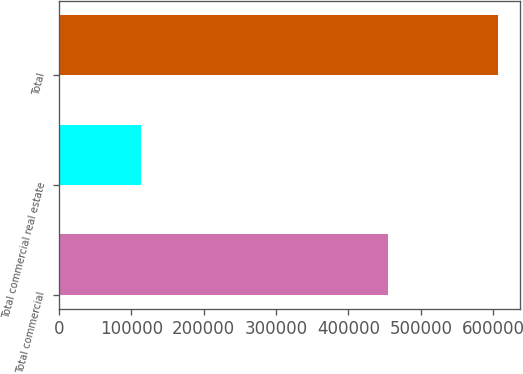<chart> <loc_0><loc_0><loc_500><loc_500><bar_chart><fcel>Total commercial<fcel>Total commercial real estate<fcel>Total<nl><fcel>454277<fcel>113992<fcel>606048<nl></chart> 